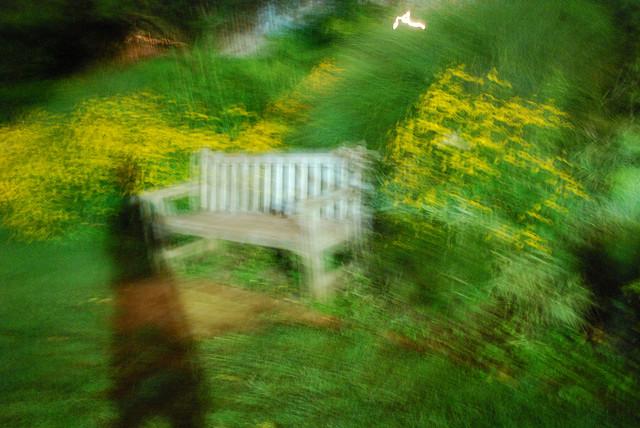Is there a bench?
Give a very brief answer. Yes. Is this picture clear?
Keep it brief. No. Do you see a shadow of a person?
Concise answer only. Yes. 